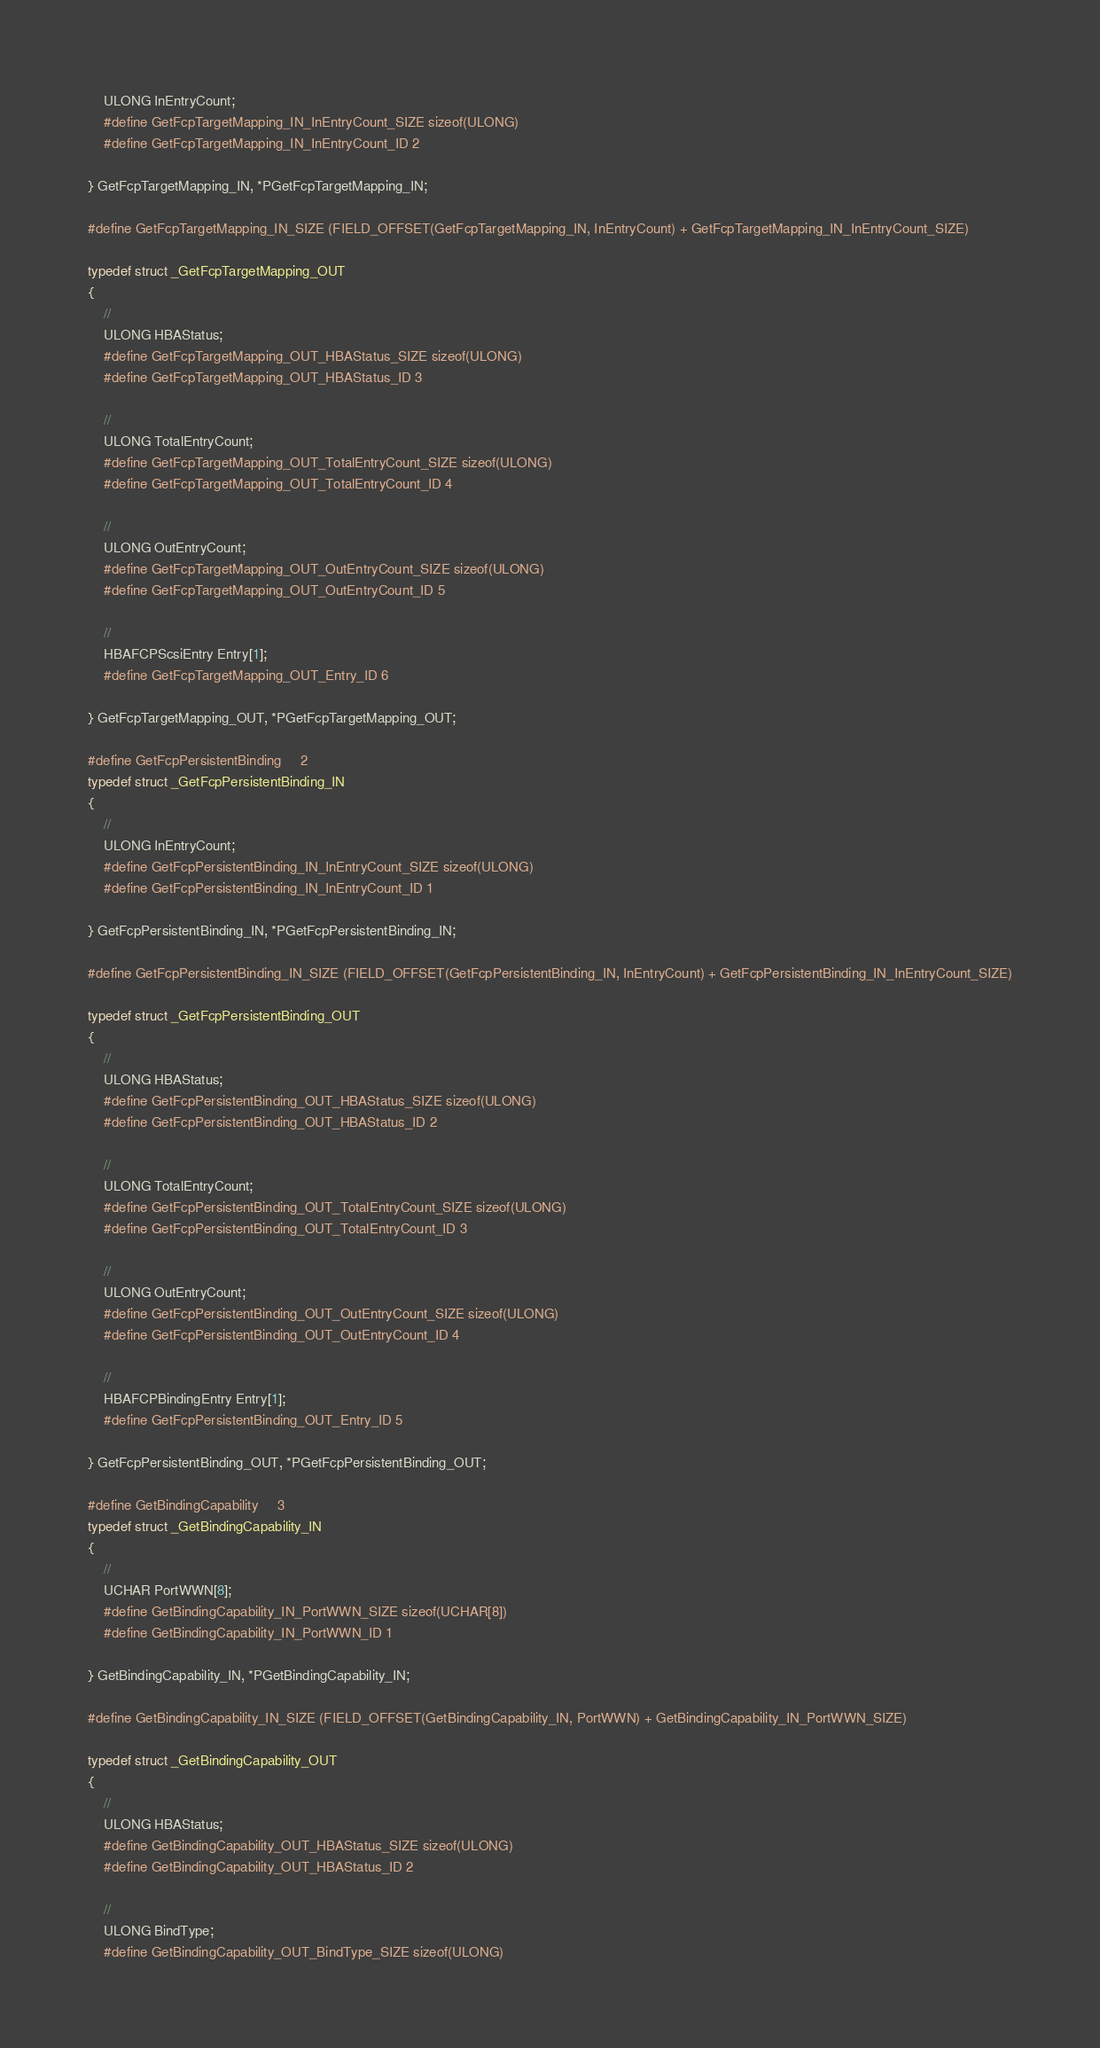<code> <loc_0><loc_0><loc_500><loc_500><_C_>    ULONG InEntryCount;
    #define GetFcpTargetMapping_IN_InEntryCount_SIZE sizeof(ULONG)
    #define GetFcpTargetMapping_IN_InEntryCount_ID 2

} GetFcpTargetMapping_IN, *PGetFcpTargetMapping_IN;

#define GetFcpTargetMapping_IN_SIZE (FIELD_OFFSET(GetFcpTargetMapping_IN, InEntryCount) + GetFcpTargetMapping_IN_InEntryCount_SIZE)

typedef struct _GetFcpTargetMapping_OUT
{
    // 
    ULONG HBAStatus;
    #define GetFcpTargetMapping_OUT_HBAStatus_SIZE sizeof(ULONG)
    #define GetFcpTargetMapping_OUT_HBAStatus_ID 3

    // 
    ULONG TotalEntryCount;
    #define GetFcpTargetMapping_OUT_TotalEntryCount_SIZE sizeof(ULONG)
    #define GetFcpTargetMapping_OUT_TotalEntryCount_ID 4

    // 
    ULONG OutEntryCount;
    #define GetFcpTargetMapping_OUT_OutEntryCount_SIZE sizeof(ULONG)
    #define GetFcpTargetMapping_OUT_OutEntryCount_ID 5

    // 
    HBAFCPScsiEntry Entry[1];
    #define GetFcpTargetMapping_OUT_Entry_ID 6

} GetFcpTargetMapping_OUT, *PGetFcpTargetMapping_OUT;

#define GetFcpPersistentBinding     2
typedef struct _GetFcpPersistentBinding_IN
{
    // 
    ULONG InEntryCount;
    #define GetFcpPersistentBinding_IN_InEntryCount_SIZE sizeof(ULONG)
    #define GetFcpPersistentBinding_IN_InEntryCount_ID 1

} GetFcpPersistentBinding_IN, *PGetFcpPersistentBinding_IN;

#define GetFcpPersistentBinding_IN_SIZE (FIELD_OFFSET(GetFcpPersistentBinding_IN, InEntryCount) + GetFcpPersistentBinding_IN_InEntryCount_SIZE)

typedef struct _GetFcpPersistentBinding_OUT
{
    // 
    ULONG HBAStatus;
    #define GetFcpPersistentBinding_OUT_HBAStatus_SIZE sizeof(ULONG)
    #define GetFcpPersistentBinding_OUT_HBAStatus_ID 2

    // 
    ULONG TotalEntryCount;
    #define GetFcpPersistentBinding_OUT_TotalEntryCount_SIZE sizeof(ULONG)
    #define GetFcpPersistentBinding_OUT_TotalEntryCount_ID 3

    // 
    ULONG OutEntryCount;
    #define GetFcpPersistentBinding_OUT_OutEntryCount_SIZE sizeof(ULONG)
    #define GetFcpPersistentBinding_OUT_OutEntryCount_ID 4

    // 
    HBAFCPBindingEntry Entry[1];
    #define GetFcpPersistentBinding_OUT_Entry_ID 5

} GetFcpPersistentBinding_OUT, *PGetFcpPersistentBinding_OUT;

#define GetBindingCapability     3
typedef struct _GetBindingCapability_IN
{
    // 
    UCHAR PortWWN[8];
    #define GetBindingCapability_IN_PortWWN_SIZE sizeof(UCHAR[8])
    #define GetBindingCapability_IN_PortWWN_ID 1

} GetBindingCapability_IN, *PGetBindingCapability_IN;

#define GetBindingCapability_IN_SIZE (FIELD_OFFSET(GetBindingCapability_IN, PortWWN) + GetBindingCapability_IN_PortWWN_SIZE)

typedef struct _GetBindingCapability_OUT
{
    // 
    ULONG HBAStatus;
    #define GetBindingCapability_OUT_HBAStatus_SIZE sizeof(ULONG)
    #define GetBindingCapability_OUT_HBAStatus_ID 2

    // 
    ULONG BindType;
    #define GetBindingCapability_OUT_BindType_SIZE sizeof(ULONG)</code> 